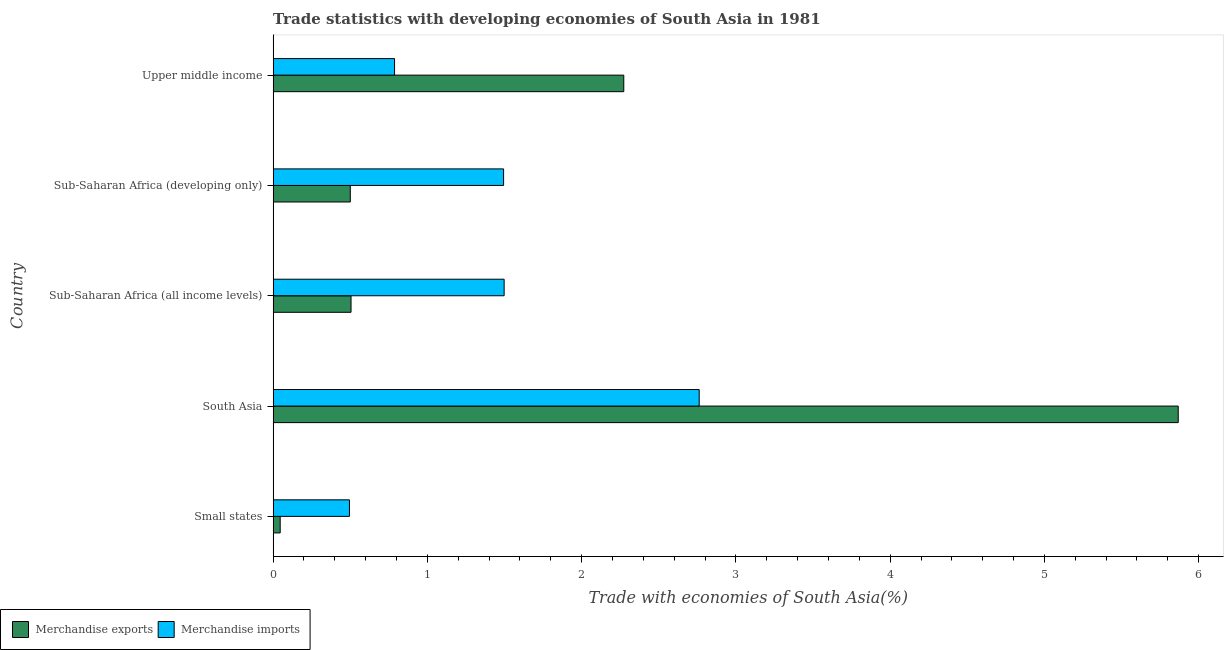How many different coloured bars are there?
Provide a succinct answer. 2. Are the number of bars per tick equal to the number of legend labels?
Ensure brevity in your answer.  Yes. How many bars are there on the 5th tick from the top?
Provide a succinct answer. 2. How many bars are there on the 5th tick from the bottom?
Your response must be concise. 2. What is the label of the 5th group of bars from the top?
Provide a short and direct response. Small states. In how many cases, is the number of bars for a given country not equal to the number of legend labels?
Give a very brief answer. 0. What is the merchandise exports in South Asia?
Keep it short and to the point. 5.87. Across all countries, what is the maximum merchandise imports?
Offer a very short reply. 2.76. Across all countries, what is the minimum merchandise imports?
Your response must be concise. 0.49. In which country was the merchandise imports maximum?
Offer a terse response. South Asia. In which country was the merchandise exports minimum?
Offer a terse response. Small states. What is the total merchandise exports in the graph?
Ensure brevity in your answer.  9.19. What is the difference between the merchandise imports in Sub-Saharan Africa (developing only) and that in Upper middle income?
Your answer should be very brief. 0.71. What is the difference between the merchandise imports in Sub-Saharan Africa (developing only) and the merchandise exports in Upper middle income?
Your response must be concise. -0.78. What is the average merchandise imports per country?
Your answer should be very brief. 1.41. What is the difference between the merchandise imports and merchandise exports in Small states?
Give a very brief answer. 0.45. What is the ratio of the merchandise exports in South Asia to that in Sub-Saharan Africa (developing only)?
Make the answer very short. 11.73. Is the difference between the merchandise imports in Small states and South Asia greater than the difference between the merchandise exports in Small states and South Asia?
Offer a very short reply. Yes. What is the difference between the highest and the second highest merchandise imports?
Offer a terse response. 1.26. What is the difference between the highest and the lowest merchandise imports?
Make the answer very short. 2.27. In how many countries, is the merchandise imports greater than the average merchandise imports taken over all countries?
Offer a very short reply. 3. Is the sum of the merchandise imports in Sub-Saharan Africa (all income levels) and Sub-Saharan Africa (developing only) greater than the maximum merchandise exports across all countries?
Offer a very short reply. No. Are all the bars in the graph horizontal?
Make the answer very short. Yes. How many countries are there in the graph?
Your answer should be compact. 5. What is the difference between two consecutive major ticks on the X-axis?
Your answer should be compact. 1. Are the values on the major ticks of X-axis written in scientific E-notation?
Your answer should be very brief. No. Does the graph contain any zero values?
Keep it short and to the point. No. Where does the legend appear in the graph?
Your answer should be very brief. Bottom left. How are the legend labels stacked?
Give a very brief answer. Horizontal. What is the title of the graph?
Your answer should be compact. Trade statistics with developing economies of South Asia in 1981. Does "Fixed telephone" appear as one of the legend labels in the graph?
Make the answer very short. No. What is the label or title of the X-axis?
Make the answer very short. Trade with economies of South Asia(%). What is the Trade with economies of South Asia(%) of Merchandise exports in Small states?
Your answer should be very brief. 0.05. What is the Trade with economies of South Asia(%) of Merchandise imports in Small states?
Your answer should be very brief. 0.49. What is the Trade with economies of South Asia(%) in Merchandise exports in South Asia?
Keep it short and to the point. 5.87. What is the Trade with economies of South Asia(%) in Merchandise imports in South Asia?
Ensure brevity in your answer.  2.76. What is the Trade with economies of South Asia(%) in Merchandise exports in Sub-Saharan Africa (all income levels)?
Offer a terse response. 0.51. What is the Trade with economies of South Asia(%) in Merchandise imports in Sub-Saharan Africa (all income levels)?
Offer a very short reply. 1.5. What is the Trade with economies of South Asia(%) of Merchandise exports in Sub-Saharan Africa (developing only)?
Give a very brief answer. 0.5. What is the Trade with economies of South Asia(%) in Merchandise imports in Sub-Saharan Africa (developing only)?
Keep it short and to the point. 1.49. What is the Trade with economies of South Asia(%) of Merchandise exports in Upper middle income?
Your answer should be very brief. 2.27. What is the Trade with economies of South Asia(%) in Merchandise imports in Upper middle income?
Provide a short and direct response. 0.79. Across all countries, what is the maximum Trade with economies of South Asia(%) of Merchandise exports?
Your answer should be compact. 5.87. Across all countries, what is the maximum Trade with economies of South Asia(%) in Merchandise imports?
Make the answer very short. 2.76. Across all countries, what is the minimum Trade with economies of South Asia(%) of Merchandise exports?
Your answer should be compact. 0.05. Across all countries, what is the minimum Trade with economies of South Asia(%) in Merchandise imports?
Provide a succinct answer. 0.49. What is the total Trade with economies of South Asia(%) of Merchandise exports in the graph?
Make the answer very short. 9.19. What is the total Trade with economies of South Asia(%) of Merchandise imports in the graph?
Your response must be concise. 7.04. What is the difference between the Trade with economies of South Asia(%) of Merchandise exports in Small states and that in South Asia?
Give a very brief answer. -5.82. What is the difference between the Trade with economies of South Asia(%) of Merchandise imports in Small states and that in South Asia?
Keep it short and to the point. -2.27. What is the difference between the Trade with economies of South Asia(%) of Merchandise exports in Small states and that in Sub-Saharan Africa (all income levels)?
Your response must be concise. -0.46. What is the difference between the Trade with economies of South Asia(%) of Merchandise imports in Small states and that in Sub-Saharan Africa (all income levels)?
Make the answer very short. -1. What is the difference between the Trade with economies of South Asia(%) in Merchandise exports in Small states and that in Sub-Saharan Africa (developing only)?
Provide a short and direct response. -0.45. What is the difference between the Trade with economies of South Asia(%) in Merchandise imports in Small states and that in Sub-Saharan Africa (developing only)?
Your answer should be compact. -1. What is the difference between the Trade with economies of South Asia(%) in Merchandise exports in Small states and that in Upper middle income?
Keep it short and to the point. -2.23. What is the difference between the Trade with economies of South Asia(%) of Merchandise imports in Small states and that in Upper middle income?
Give a very brief answer. -0.29. What is the difference between the Trade with economies of South Asia(%) of Merchandise exports in South Asia and that in Sub-Saharan Africa (all income levels)?
Ensure brevity in your answer.  5.36. What is the difference between the Trade with economies of South Asia(%) of Merchandise imports in South Asia and that in Sub-Saharan Africa (all income levels)?
Give a very brief answer. 1.26. What is the difference between the Trade with economies of South Asia(%) in Merchandise exports in South Asia and that in Sub-Saharan Africa (developing only)?
Your answer should be compact. 5.37. What is the difference between the Trade with economies of South Asia(%) in Merchandise imports in South Asia and that in Sub-Saharan Africa (developing only)?
Keep it short and to the point. 1.27. What is the difference between the Trade with economies of South Asia(%) in Merchandise exports in South Asia and that in Upper middle income?
Your answer should be compact. 3.59. What is the difference between the Trade with economies of South Asia(%) of Merchandise imports in South Asia and that in Upper middle income?
Give a very brief answer. 1.97. What is the difference between the Trade with economies of South Asia(%) of Merchandise exports in Sub-Saharan Africa (all income levels) and that in Sub-Saharan Africa (developing only)?
Make the answer very short. 0. What is the difference between the Trade with economies of South Asia(%) of Merchandise imports in Sub-Saharan Africa (all income levels) and that in Sub-Saharan Africa (developing only)?
Your response must be concise. 0. What is the difference between the Trade with economies of South Asia(%) of Merchandise exports in Sub-Saharan Africa (all income levels) and that in Upper middle income?
Give a very brief answer. -1.77. What is the difference between the Trade with economies of South Asia(%) of Merchandise imports in Sub-Saharan Africa (all income levels) and that in Upper middle income?
Your answer should be compact. 0.71. What is the difference between the Trade with economies of South Asia(%) in Merchandise exports in Sub-Saharan Africa (developing only) and that in Upper middle income?
Ensure brevity in your answer.  -1.77. What is the difference between the Trade with economies of South Asia(%) of Merchandise imports in Sub-Saharan Africa (developing only) and that in Upper middle income?
Keep it short and to the point. 0.71. What is the difference between the Trade with economies of South Asia(%) of Merchandise exports in Small states and the Trade with economies of South Asia(%) of Merchandise imports in South Asia?
Your answer should be very brief. -2.72. What is the difference between the Trade with economies of South Asia(%) of Merchandise exports in Small states and the Trade with economies of South Asia(%) of Merchandise imports in Sub-Saharan Africa (all income levels)?
Offer a very short reply. -1.45. What is the difference between the Trade with economies of South Asia(%) of Merchandise exports in Small states and the Trade with economies of South Asia(%) of Merchandise imports in Sub-Saharan Africa (developing only)?
Make the answer very short. -1.45. What is the difference between the Trade with economies of South Asia(%) of Merchandise exports in Small states and the Trade with economies of South Asia(%) of Merchandise imports in Upper middle income?
Offer a very short reply. -0.74. What is the difference between the Trade with economies of South Asia(%) in Merchandise exports in South Asia and the Trade with economies of South Asia(%) in Merchandise imports in Sub-Saharan Africa (all income levels)?
Your answer should be very brief. 4.37. What is the difference between the Trade with economies of South Asia(%) in Merchandise exports in South Asia and the Trade with economies of South Asia(%) in Merchandise imports in Sub-Saharan Africa (developing only)?
Your answer should be compact. 4.37. What is the difference between the Trade with economies of South Asia(%) of Merchandise exports in South Asia and the Trade with economies of South Asia(%) of Merchandise imports in Upper middle income?
Give a very brief answer. 5.08. What is the difference between the Trade with economies of South Asia(%) in Merchandise exports in Sub-Saharan Africa (all income levels) and the Trade with economies of South Asia(%) in Merchandise imports in Sub-Saharan Africa (developing only)?
Keep it short and to the point. -0.99. What is the difference between the Trade with economies of South Asia(%) in Merchandise exports in Sub-Saharan Africa (all income levels) and the Trade with economies of South Asia(%) in Merchandise imports in Upper middle income?
Provide a short and direct response. -0.28. What is the difference between the Trade with economies of South Asia(%) of Merchandise exports in Sub-Saharan Africa (developing only) and the Trade with economies of South Asia(%) of Merchandise imports in Upper middle income?
Make the answer very short. -0.29. What is the average Trade with economies of South Asia(%) in Merchandise exports per country?
Ensure brevity in your answer.  1.84. What is the average Trade with economies of South Asia(%) in Merchandise imports per country?
Offer a very short reply. 1.41. What is the difference between the Trade with economies of South Asia(%) of Merchandise exports and Trade with economies of South Asia(%) of Merchandise imports in Small states?
Keep it short and to the point. -0.45. What is the difference between the Trade with economies of South Asia(%) of Merchandise exports and Trade with economies of South Asia(%) of Merchandise imports in South Asia?
Make the answer very short. 3.11. What is the difference between the Trade with economies of South Asia(%) of Merchandise exports and Trade with economies of South Asia(%) of Merchandise imports in Sub-Saharan Africa (all income levels)?
Provide a succinct answer. -0.99. What is the difference between the Trade with economies of South Asia(%) in Merchandise exports and Trade with economies of South Asia(%) in Merchandise imports in Sub-Saharan Africa (developing only)?
Provide a short and direct response. -0.99. What is the difference between the Trade with economies of South Asia(%) of Merchandise exports and Trade with economies of South Asia(%) of Merchandise imports in Upper middle income?
Provide a succinct answer. 1.49. What is the ratio of the Trade with economies of South Asia(%) of Merchandise exports in Small states to that in South Asia?
Your answer should be very brief. 0.01. What is the ratio of the Trade with economies of South Asia(%) of Merchandise imports in Small states to that in South Asia?
Your response must be concise. 0.18. What is the ratio of the Trade with economies of South Asia(%) in Merchandise exports in Small states to that in Sub-Saharan Africa (all income levels)?
Provide a short and direct response. 0.09. What is the ratio of the Trade with economies of South Asia(%) of Merchandise imports in Small states to that in Sub-Saharan Africa (all income levels)?
Keep it short and to the point. 0.33. What is the ratio of the Trade with economies of South Asia(%) in Merchandise exports in Small states to that in Sub-Saharan Africa (developing only)?
Keep it short and to the point. 0.09. What is the ratio of the Trade with economies of South Asia(%) in Merchandise imports in Small states to that in Sub-Saharan Africa (developing only)?
Provide a succinct answer. 0.33. What is the ratio of the Trade with economies of South Asia(%) in Merchandise exports in Small states to that in Upper middle income?
Provide a short and direct response. 0.02. What is the ratio of the Trade with economies of South Asia(%) of Merchandise imports in Small states to that in Upper middle income?
Your answer should be very brief. 0.63. What is the ratio of the Trade with economies of South Asia(%) in Merchandise exports in South Asia to that in Sub-Saharan Africa (all income levels)?
Keep it short and to the point. 11.62. What is the ratio of the Trade with economies of South Asia(%) in Merchandise imports in South Asia to that in Sub-Saharan Africa (all income levels)?
Ensure brevity in your answer.  1.84. What is the ratio of the Trade with economies of South Asia(%) of Merchandise exports in South Asia to that in Sub-Saharan Africa (developing only)?
Keep it short and to the point. 11.73. What is the ratio of the Trade with economies of South Asia(%) in Merchandise imports in South Asia to that in Sub-Saharan Africa (developing only)?
Offer a terse response. 1.85. What is the ratio of the Trade with economies of South Asia(%) of Merchandise exports in South Asia to that in Upper middle income?
Your answer should be very brief. 2.58. What is the ratio of the Trade with economies of South Asia(%) of Merchandise imports in South Asia to that in Upper middle income?
Provide a succinct answer. 3.51. What is the ratio of the Trade with economies of South Asia(%) in Merchandise exports in Sub-Saharan Africa (all income levels) to that in Sub-Saharan Africa (developing only)?
Provide a succinct answer. 1.01. What is the ratio of the Trade with economies of South Asia(%) of Merchandise imports in Sub-Saharan Africa (all income levels) to that in Sub-Saharan Africa (developing only)?
Provide a succinct answer. 1. What is the ratio of the Trade with economies of South Asia(%) of Merchandise exports in Sub-Saharan Africa (all income levels) to that in Upper middle income?
Ensure brevity in your answer.  0.22. What is the ratio of the Trade with economies of South Asia(%) of Merchandise imports in Sub-Saharan Africa (all income levels) to that in Upper middle income?
Keep it short and to the point. 1.9. What is the ratio of the Trade with economies of South Asia(%) of Merchandise exports in Sub-Saharan Africa (developing only) to that in Upper middle income?
Your answer should be compact. 0.22. What is the ratio of the Trade with economies of South Asia(%) in Merchandise imports in Sub-Saharan Africa (developing only) to that in Upper middle income?
Your response must be concise. 1.9. What is the difference between the highest and the second highest Trade with economies of South Asia(%) of Merchandise exports?
Make the answer very short. 3.59. What is the difference between the highest and the second highest Trade with economies of South Asia(%) of Merchandise imports?
Make the answer very short. 1.26. What is the difference between the highest and the lowest Trade with economies of South Asia(%) of Merchandise exports?
Offer a terse response. 5.82. What is the difference between the highest and the lowest Trade with economies of South Asia(%) of Merchandise imports?
Ensure brevity in your answer.  2.27. 